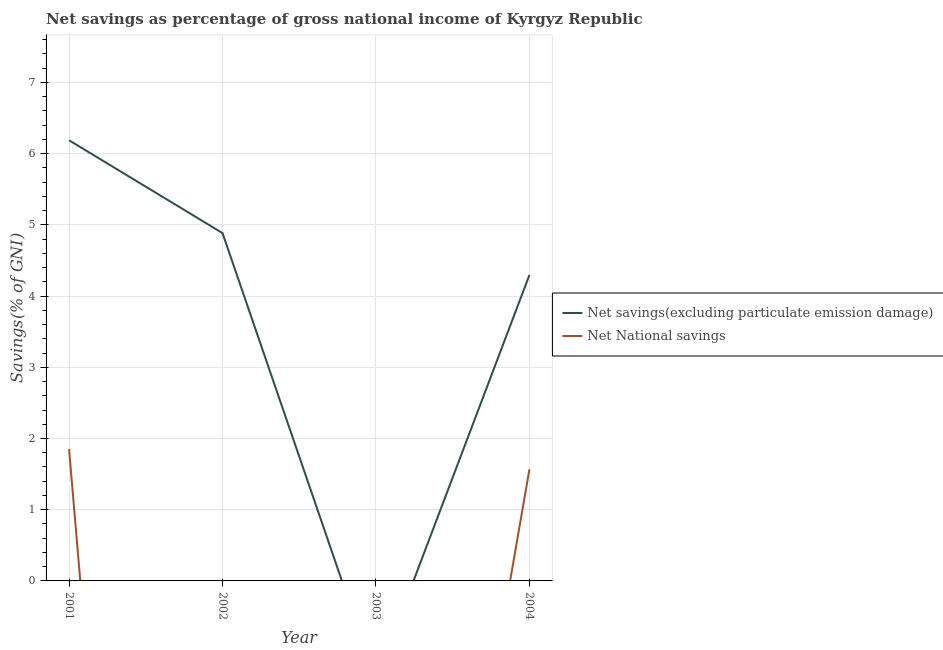Is the number of lines equal to the number of legend labels?
Offer a terse response. No. What is the net savings(excluding particulate emission damage) in 2001?
Keep it short and to the point. 6.19. Across all years, what is the maximum net national savings?
Make the answer very short. 1.85. In which year was the net national savings maximum?
Ensure brevity in your answer.  2001. What is the total net national savings in the graph?
Provide a short and direct response. 3.42. What is the difference between the net savings(excluding particulate emission damage) in 2001 and that in 2002?
Provide a short and direct response. 1.3. What is the difference between the net savings(excluding particulate emission damage) in 2003 and the net national savings in 2001?
Provide a short and direct response. -1.85. What is the average net savings(excluding particulate emission damage) per year?
Give a very brief answer. 3.84. In the year 2001, what is the difference between the net savings(excluding particulate emission damage) and net national savings?
Offer a very short reply. 4.34. What is the ratio of the net savings(excluding particulate emission damage) in 2001 to that in 2002?
Provide a succinct answer. 1.27. Is the net savings(excluding particulate emission damage) in 2002 less than that in 2004?
Ensure brevity in your answer.  No. Is the difference between the net national savings in 2001 and 2004 greater than the difference between the net savings(excluding particulate emission damage) in 2001 and 2004?
Give a very brief answer. No. What is the difference between the highest and the second highest net savings(excluding particulate emission damage)?
Offer a very short reply. 1.3. What is the difference between the highest and the lowest net national savings?
Your answer should be very brief. 1.85. Is the sum of the net savings(excluding particulate emission damage) in 2001 and 2004 greater than the maximum net national savings across all years?
Your response must be concise. Yes. What is the difference between two consecutive major ticks on the Y-axis?
Keep it short and to the point. 1. Are the values on the major ticks of Y-axis written in scientific E-notation?
Your answer should be compact. No. Does the graph contain grids?
Keep it short and to the point. Yes. Where does the legend appear in the graph?
Make the answer very short. Center right. How are the legend labels stacked?
Make the answer very short. Vertical. What is the title of the graph?
Offer a very short reply. Net savings as percentage of gross national income of Kyrgyz Republic. Does "National Tourists" appear as one of the legend labels in the graph?
Provide a succinct answer. No. What is the label or title of the X-axis?
Provide a short and direct response. Year. What is the label or title of the Y-axis?
Your response must be concise. Savings(% of GNI). What is the Savings(% of GNI) of Net savings(excluding particulate emission damage) in 2001?
Ensure brevity in your answer.  6.19. What is the Savings(% of GNI) in Net National savings in 2001?
Give a very brief answer. 1.85. What is the Savings(% of GNI) of Net savings(excluding particulate emission damage) in 2002?
Provide a short and direct response. 4.88. What is the Savings(% of GNI) in Net National savings in 2002?
Give a very brief answer. 0. What is the Savings(% of GNI) in Net savings(excluding particulate emission damage) in 2004?
Keep it short and to the point. 4.29. What is the Savings(% of GNI) in Net National savings in 2004?
Keep it short and to the point. 1.57. Across all years, what is the maximum Savings(% of GNI) of Net savings(excluding particulate emission damage)?
Keep it short and to the point. 6.19. Across all years, what is the maximum Savings(% of GNI) in Net National savings?
Ensure brevity in your answer.  1.85. Across all years, what is the minimum Savings(% of GNI) in Net savings(excluding particulate emission damage)?
Provide a short and direct response. 0. Across all years, what is the minimum Savings(% of GNI) in Net National savings?
Your response must be concise. 0. What is the total Savings(% of GNI) in Net savings(excluding particulate emission damage) in the graph?
Provide a succinct answer. 15.37. What is the total Savings(% of GNI) of Net National savings in the graph?
Ensure brevity in your answer.  3.42. What is the difference between the Savings(% of GNI) of Net savings(excluding particulate emission damage) in 2001 and that in 2002?
Your answer should be compact. 1.3. What is the difference between the Savings(% of GNI) in Net savings(excluding particulate emission damage) in 2001 and that in 2004?
Your answer should be very brief. 1.89. What is the difference between the Savings(% of GNI) in Net National savings in 2001 and that in 2004?
Keep it short and to the point. 0.29. What is the difference between the Savings(% of GNI) of Net savings(excluding particulate emission damage) in 2002 and that in 2004?
Your answer should be very brief. 0.59. What is the difference between the Savings(% of GNI) of Net savings(excluding particulate emission damage) in 2001 and the Savings(% of GNI) of Net National savings in 2004?
Make the answer very short. 4.62. What is the difference between the Savings(% of GNI) of Net savings(excluding particulate emission damage) in 2002 and the Savings(% of GNI) of Net National savings in 2004?
Make the answer very short. 3.32. What is the average Savings(% of GNI) of Net savings(excluding particulate emission damage) per year?
Give a very brief answer. 3.84. What is the average Savings(% of GNI) in Net National savings per year?
Your answer should be very brief. 0.85. In the year 2001, what is the difference between the Savings(% of GNI) in Net savings(excluding particulate emission damage) and Savings(% of GNI) in Net National savings?
Offer a very short reply. 4.34. In the year 2004, what is the difference between the Savings(% of GNI) of Net savings(excluding particulate emission damage) and Savings(% of GNI) of Net National savings?
Your answer should be compact. 2.73. What is the ratio of the Savings(% of GNI) in Net savings(excluding particulate emission damage) in 2001 to that in 2002?
Your response must be concise. 1.27. What is the ratio of the Savings(% of GNI) in Net savings(excluding particulate emission damage) in 2001 to that in 2004?
Offer a very short reply. 1.44. What is the ratio of the Savings(% of GNI) of Net National savings in 2001 to that in 2004?
Offer a terse response. 1.18. What is the ratio of the Savings(% of GNI) of Net savings(excluding particulate emission damage) in 2002 to that in 2004?
Provide a short and direct response. 1.14. What is the difference between the highest and the second highest Savings(% of GNI) in Net savings(excluding particulate emission damage)?
Provide a succinct answer. 1.3. What is the difference between the highest and the lowest Savings(% of GNI) in Net savings(excluding particulate emission damage)?
Your response must be concise. 6.19. What is the difference between the highest and the lowest Savings(% of GNI) of Net National savings?
Provide a succinct answer. 1.85. 